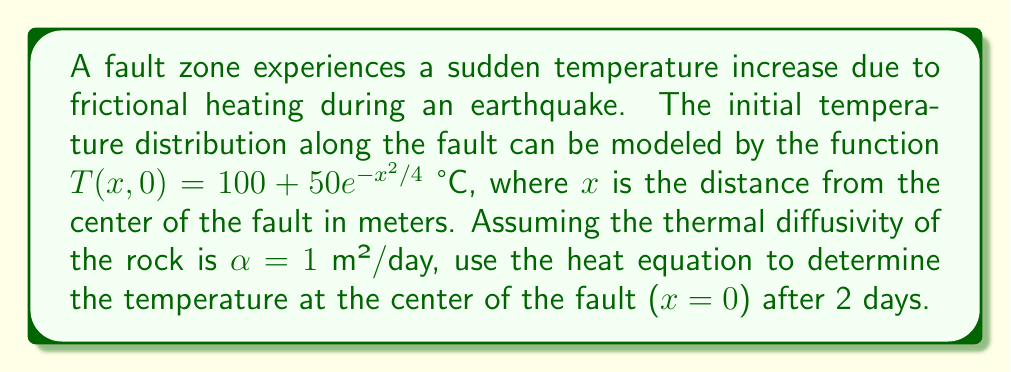Solve this math problem. To solve this problem, we'll use the one-dimensional heat equation:

$$\frac{\partial T}{\partial t} = \alpha \frac{\partial^2 T}{\partial x^2}$$

Given the initial condition $T(x,0) = 100 + 50e^{-x^2/4}$, we can use the fundamental solution of the heat equation:

$$T(x,t) = \frac{1}{\sqrt{4\pi\alpha t}} \int_{-\infty}^{\infty} T(\xi,0) e^{-\frac{(x-\xi)^2}{4\alpha t}} d\xi$$

Step 1: Substitute the initial condition into the fundamental solution:
$$T(x,t) = \frac{1}{\sqrt{4\pi\alpha t}} \int_{-\infty}^{\infty} (100 + 50e^{-\xi^2/4}) e^{-\frac{(x-\xi)^2}{4\alpha t}} d\xi$$

Step 2: Split the integral into two parts:
$$T(x,t) = \frac{100}{\sqrt{4\pi\alpha t}} \int_{-\infty}^{\infty} e^{-\frac{(x-\xi)^2}{4\alpha t}} d\xi + \frac{50}{\sqrt{4\pi\alpha t}} \int_{-\infty}^{\infty} e^{-\xi^2/4} e^{-\frac{(x-\xi)^2}{4\alpha t}} d\xi$$

Step 3: The first integral evaluates to $\sqrt{4\pi\alpha t}$, simplifying to:
$$T(x,t) = 100 + \frac{50}{\sqrt{4\pi\alpha t}} \int_{-\infty}^{\infty} e^{-\xi^2/4} e^{-\frac{(x-\xi)^2}{4\alpha t}} d\xi$$

Step 4: Evaluate the remaining integral (details omitted for brevity):
$$T(x,t) = 100 + \frac{50}{\sqrt{1 + t/2}} e^{-\frac{x^2}{4(2+t)}}$$

Step 5: For the center of the fault, $x=0$, and after 2 days, $t=2$:
$$T(0,2) = 100 + \frac{50}{\sqrt{1 + 2/2}} = 100 + \frac{50}{\sqrt{2}}$$

Step 6: Calculate the final result:
$$T(0,2) = 100 + \frac{50}{\sqrt{2}} \approx 135.36 \text{ °C}$$
Answer: 135.36 °C 